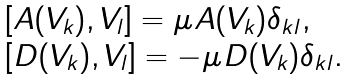Convert formula to latex. <formula><loc_0><loc_0><loc_500><loc_500>\begin{array} { l l } & [ A ( V _ { k } ) , V _ { l } ] = \mu A ( V _ { k } ) \delta _ { k l } , \\ & [ D ( V _ { k } ) , V _ { l } ] = - \mu D ( V _ { k } ) \delta _ { k l } . \end{array}</formula> 